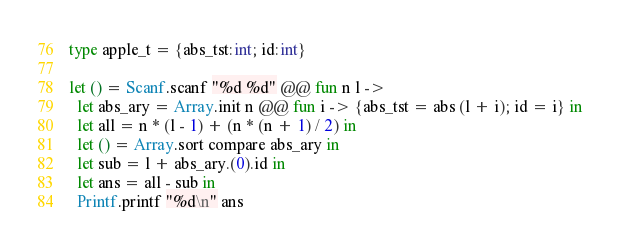<code> <loc_0><loc_0><loc_500><loc_500><_OCaml_>type apple_t = {abs_tst:int; id:int}

let () = Scanf.scanf "%d %d" @@ fun n l ->
  let abs_ary = Array.init n @@ fun i -> {abs_tst = abs (l + i); id = i} in
  let all = n * (l - 1) + (n * (n + 1) / 2) in
  let () = Array.sort compare abs_ary in
  let sub = l + abs_ary.(0).id in
  let ans = all - sub in
  Printf.printf "%d\n" ans
</code> 